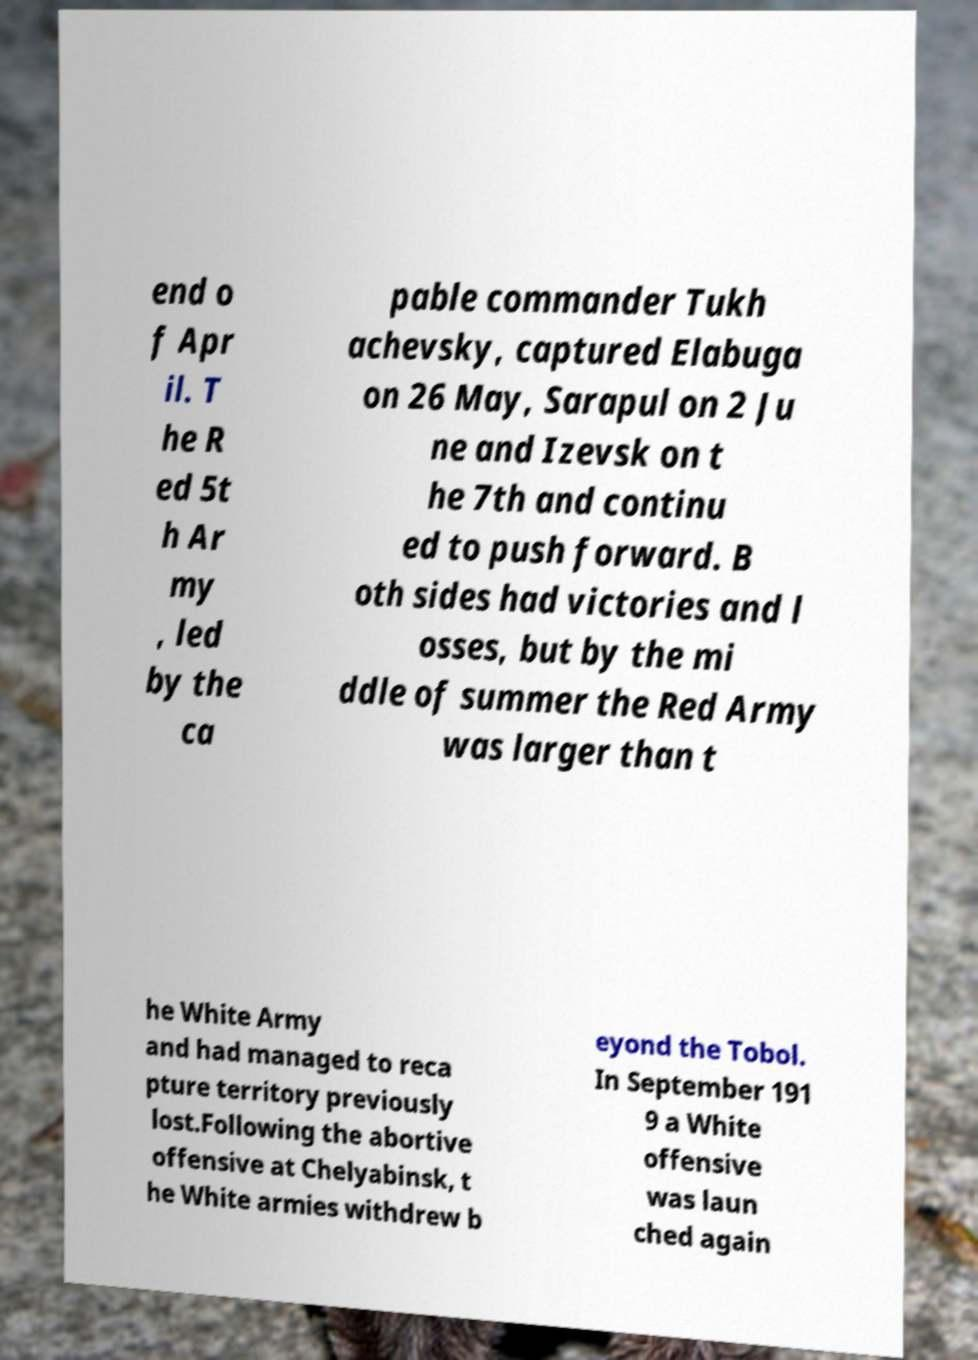Can you read and provide the text displayed in the image?This photo seems to have some interesting text. Can you extract and type it out for me? end o f Apr il. T he R ed 5t h Ar my , led by the ca pable commander Tukh achevsky, captured Elabuga on 26 May, Sarapul on 2 Ju ne and Izevsk on t he 7th and continu ed to push forward. B oth sides had victories and l osses, but by the mi ddle of summer the Red Army was larger than t he White Army and had managed to reca pture territory previously lost.Following the abortive offensive at Chelyabinsk, t he White armies withdrew b eyond the Tobol. In September 191 9 a White offensive was laun ched again 